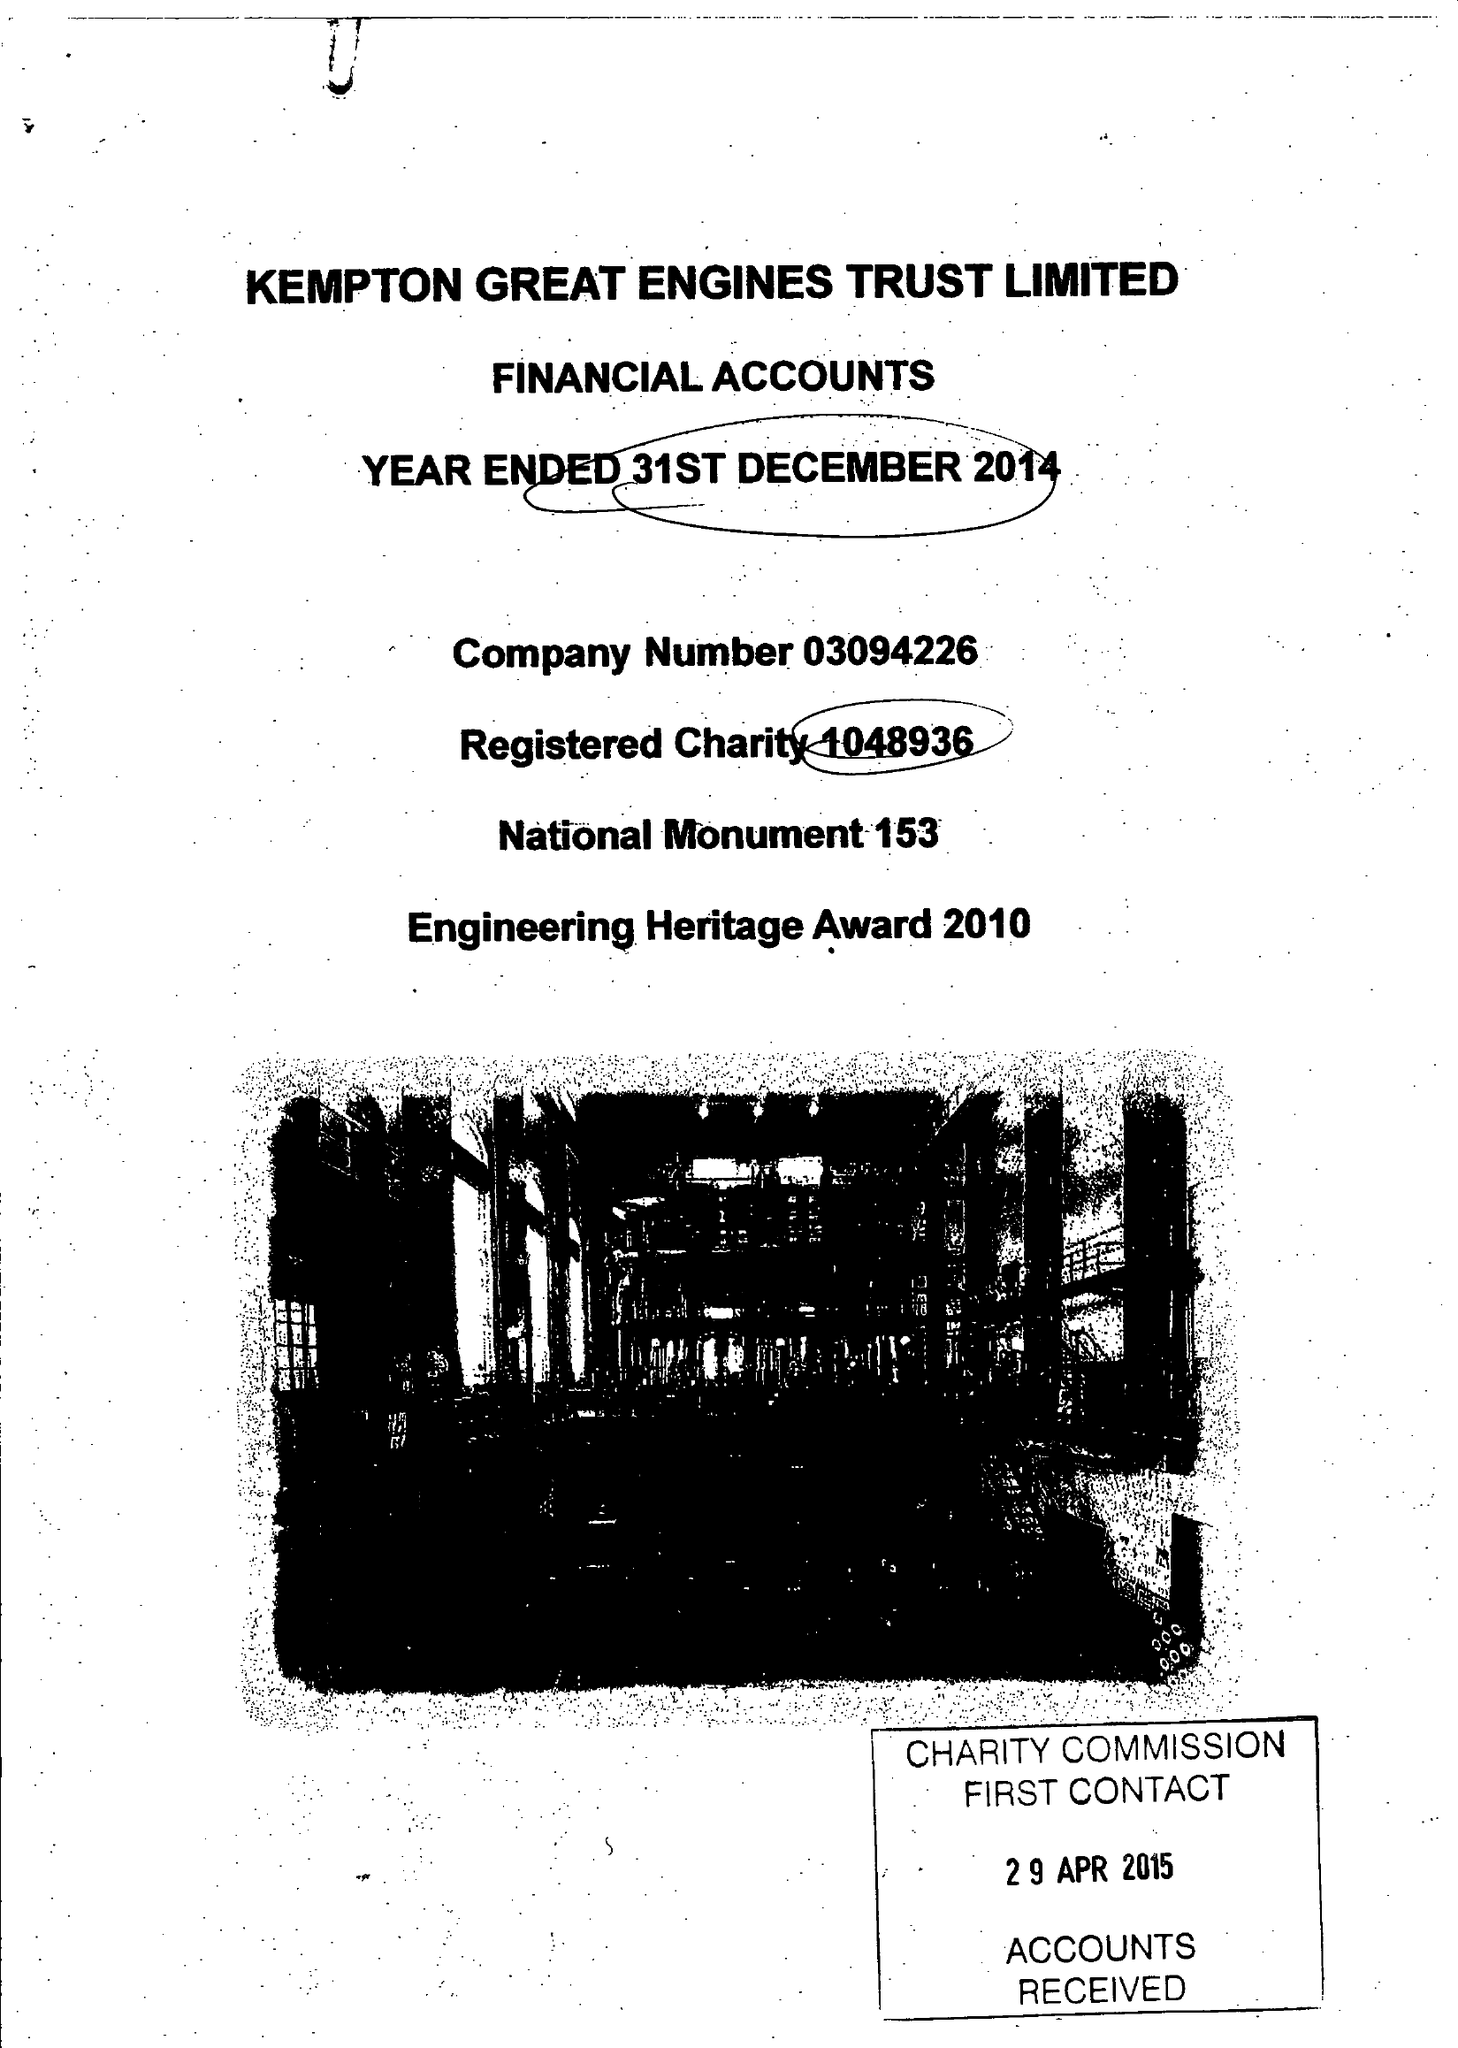What is the value for the spending_annually_in_british_pounds?
Answer the question using a single word or phrase. 25921.00 